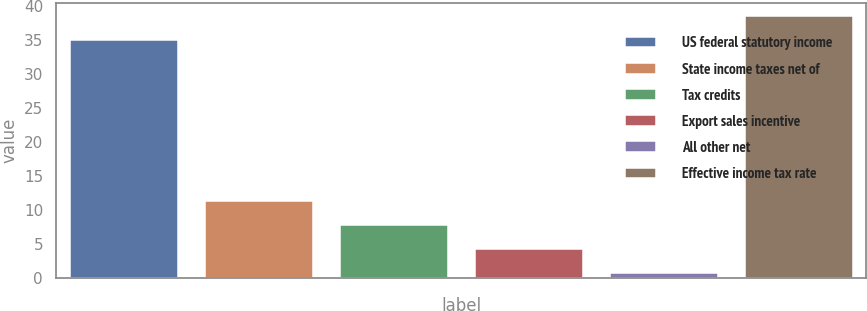Convert chart to OTSL. <chart><loc_0><loc_0><loc_500><loc_500><bar_chart><fcel>US federal statutory income<fcel>State income taxes net of<fcel>Tax credits<fcel>Export sales incentive<fcel>All other net<fcel>Effective income tax rate<nl><fcel>35<fcel>11.33<fcel>7.82<fcel>4.31<fcel>0.8<fcel>38.51<nl></chart> 